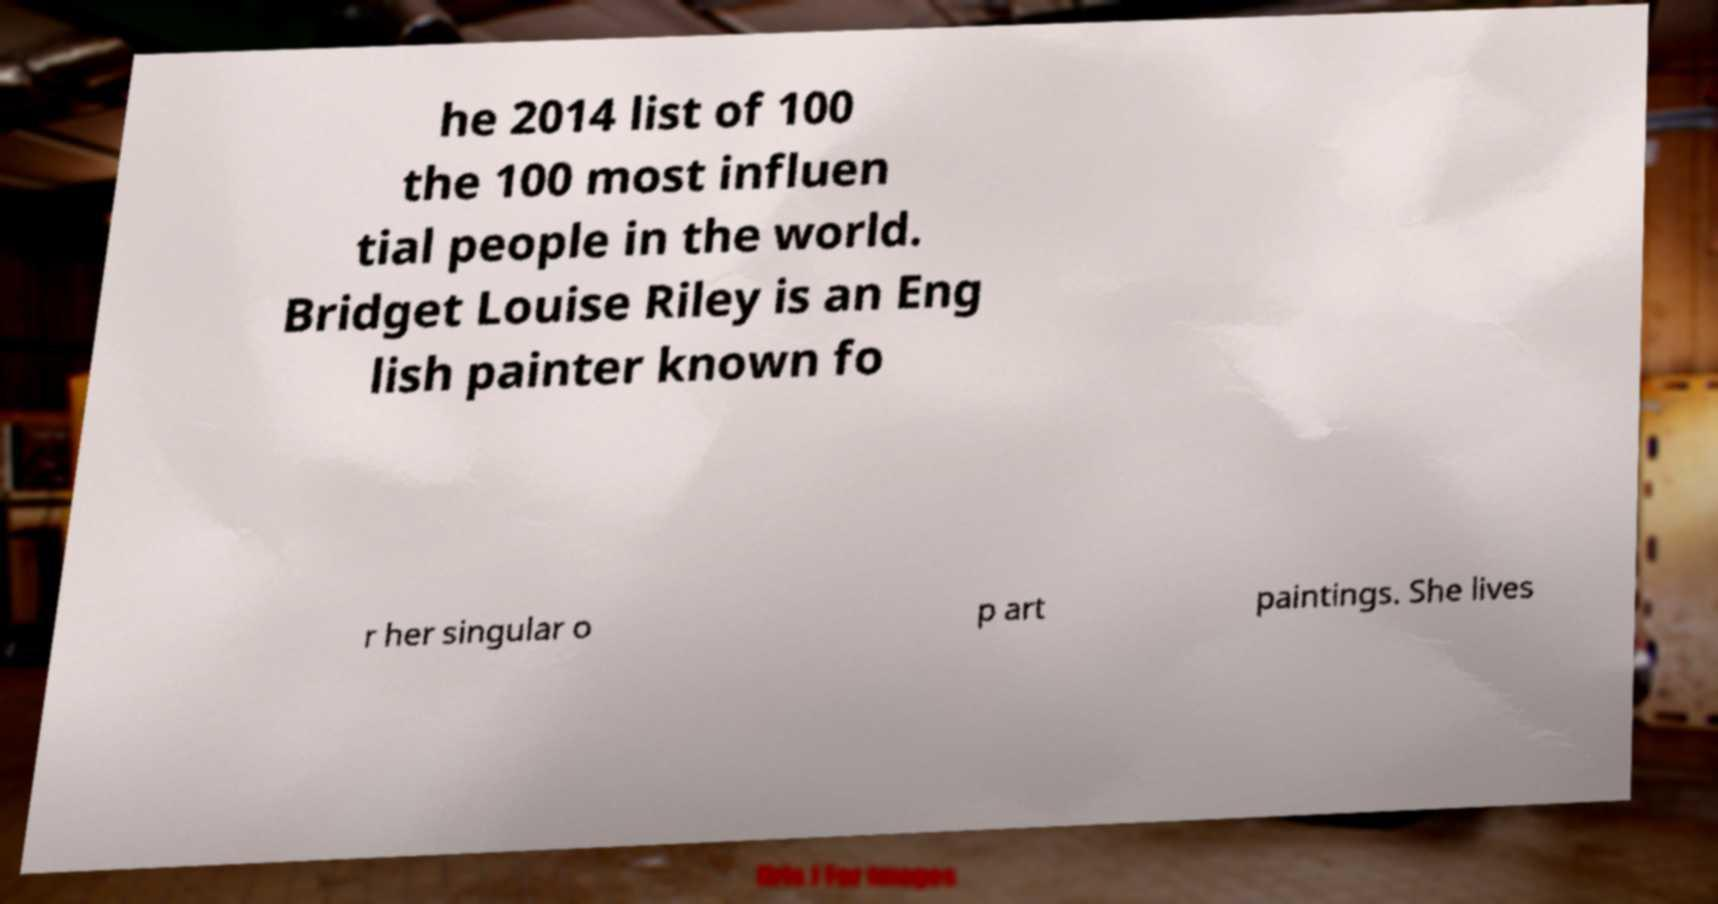Can you read and provide the text displayed in the image?This photo seems to have some interesting text. Can you extract and type it out for me? he 2014 list of 100 the 100 most influen tial people in the world. Bridget Louise Riley is an Eng lish painter known fo r her singular o p art paintings. She lives 